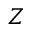<formula> <loc_0><loc_0><loc_500><loc_500>Z</formula> 